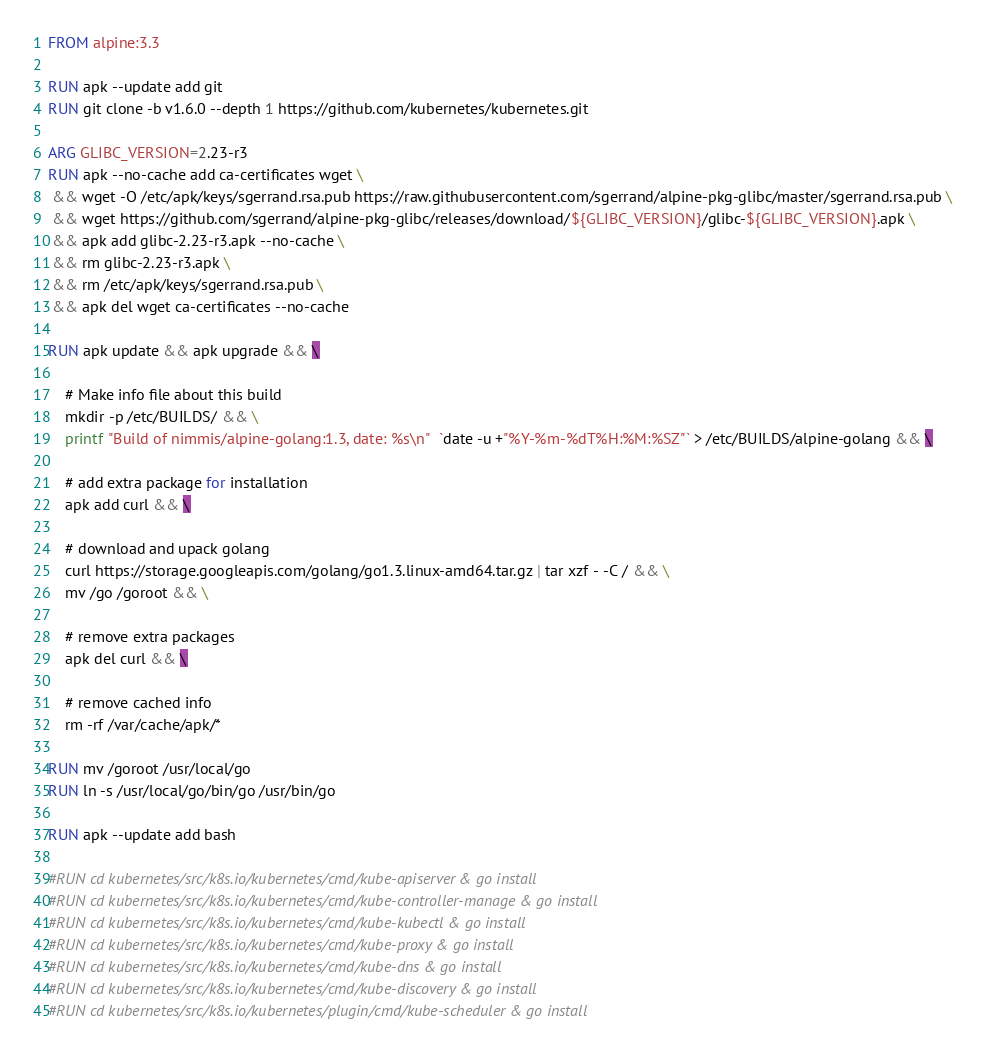Convert code to text. <code><loc_0><loc_0><loc_500><loc_500><_Dockerfile_>FROM alpine:3.3

RUN apk --update add git
RUN git clone -b v1.6.0 --depth 1 https://github.com/kubernetes/kubernetes.git

ARG GLIBC_VERSION=2.23-r3
RUN apk --no-cache add ca-certificates wget \
 && wget -O /etc/apk/keys/sgerrand.rsa.pub https://raw.githubusercontent.com/sgerrand/alpine-pkg-glibc/master/sgerrand.rsa.pub \
 && wget https://github.com/sgerrand/alpine-pkg-glibc/releases/download/${GLIBC_VERSION}/glibc-${GLIBC_VERSION}.apk \
 && apk add glibc-2.23-r3.apk --no-cache \
 && rm glibc-2.23-r3.apk \
 && rm /etc/apk/keys/sgerrand.rsa.pub \
 && apk del wget ca-certificates --no-cache

RUN apk update && apk upgrade && \

    # Make info file about this build
    mkdir -p /etc/BUILDS/ && \
    printf "Build of nimmis/alpine-golang:1.3, date: %s\n"  `date -u +"%Y-%m-%dT%H:%M:%SZ"` > /etc/BUILDS/alpine-golang && \

    # add extra package for installation  
    apk add curl && \

    # download and upack golang
    curl https://storage.googleapis.com/golang/go1.3.linux-amd64.tar.gz | tar xzf - -C / && \
    mv /go /goroot && \
 
    # remove extra packages
    apk del curl && \

    # remove cached info
    rm -rf /var/cache/apk/*

RUN mv /goroot /usr/local/go
RUN ln -s /usr/local/go/bin/go /usr/bin/go

RUN apk --update add bash

#RUN cd kubernetes/src/k8s.io/kubernetes/cmd/kube-apiserver & go install 
#RUN cd kubernetes/src/k8s.io/kubernetes/cmd/kube-controller-manage & go install 
#RUN cd kubernetes/src/k8s.io/kubernetes/cmd/kube-kubectl & go install 
#RUN cd kubernetes/src/k8s.io/kubernetes/cmd/kube-proxy & go install 
#RUN cd kubernetes/src/k8s.io/kubernetes/cmd/kube-dns & go install 
#RUN cd kubernetes/src/k8s.io/kubernetes/cmd/kube-discovery & go install 
#RUN cd kubernetes/src/k8s.io/kubernetes/plugin/cmd/kube-scheduler & go install 
</code> 